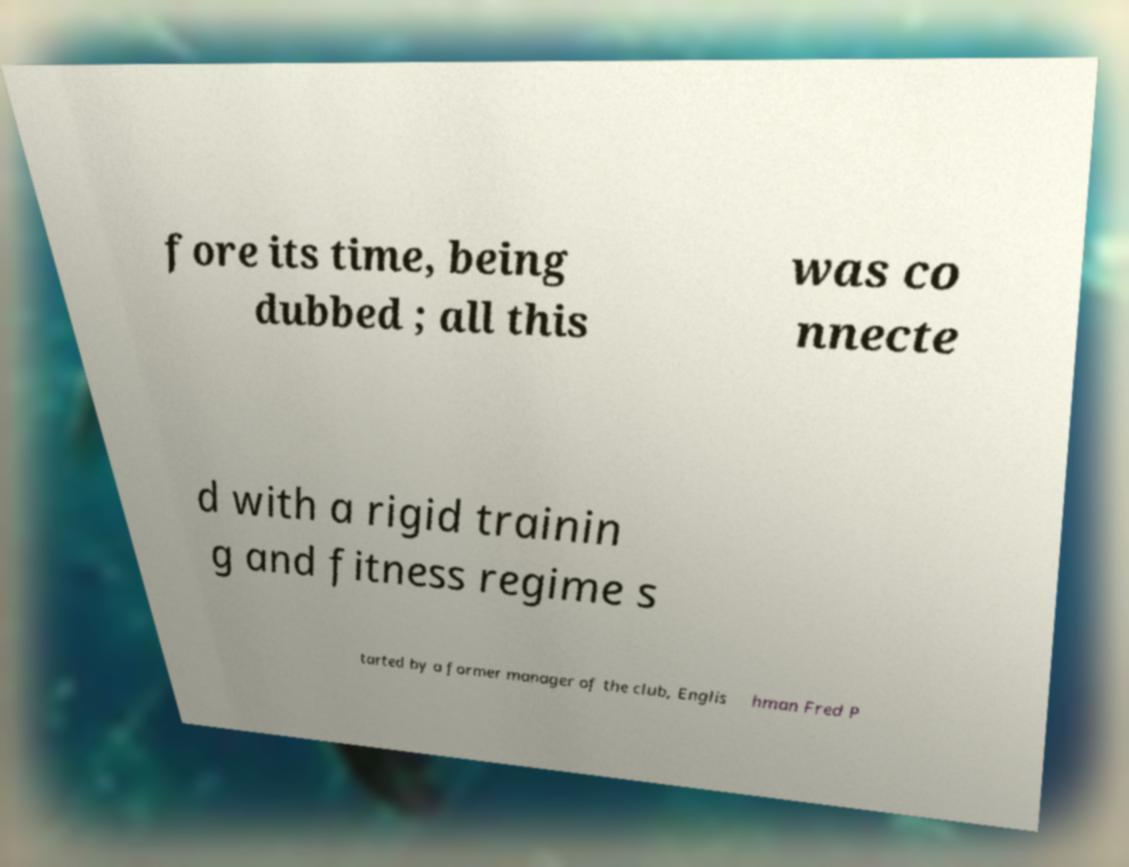Could you assist in decoding the text presented in this image and type it out clearly? fore its time, being dubbed ; all this was co nnecte d with a rigid trainin g and fitness regime s tarted by a former manager of the club, Englis hman Fred P 